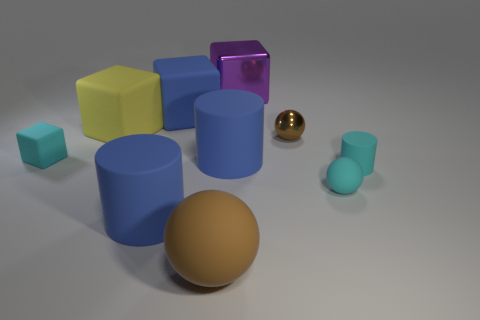Subtract all gray cylinders. Subtract all blue balls. How many cylinders are left? 3 Subtract all cylinders. How many objects are left? 7 Add 3 small cyan matte cylinders. How many small cyan matte cylinders exist? 4 Subtract 2 brown spheres. How many objects are left? 8 Subtract all green matte spheres. Subtract all brown metal things. How many objects are left? 9 Add 5 purple objects. How many purple objects are left? 6 